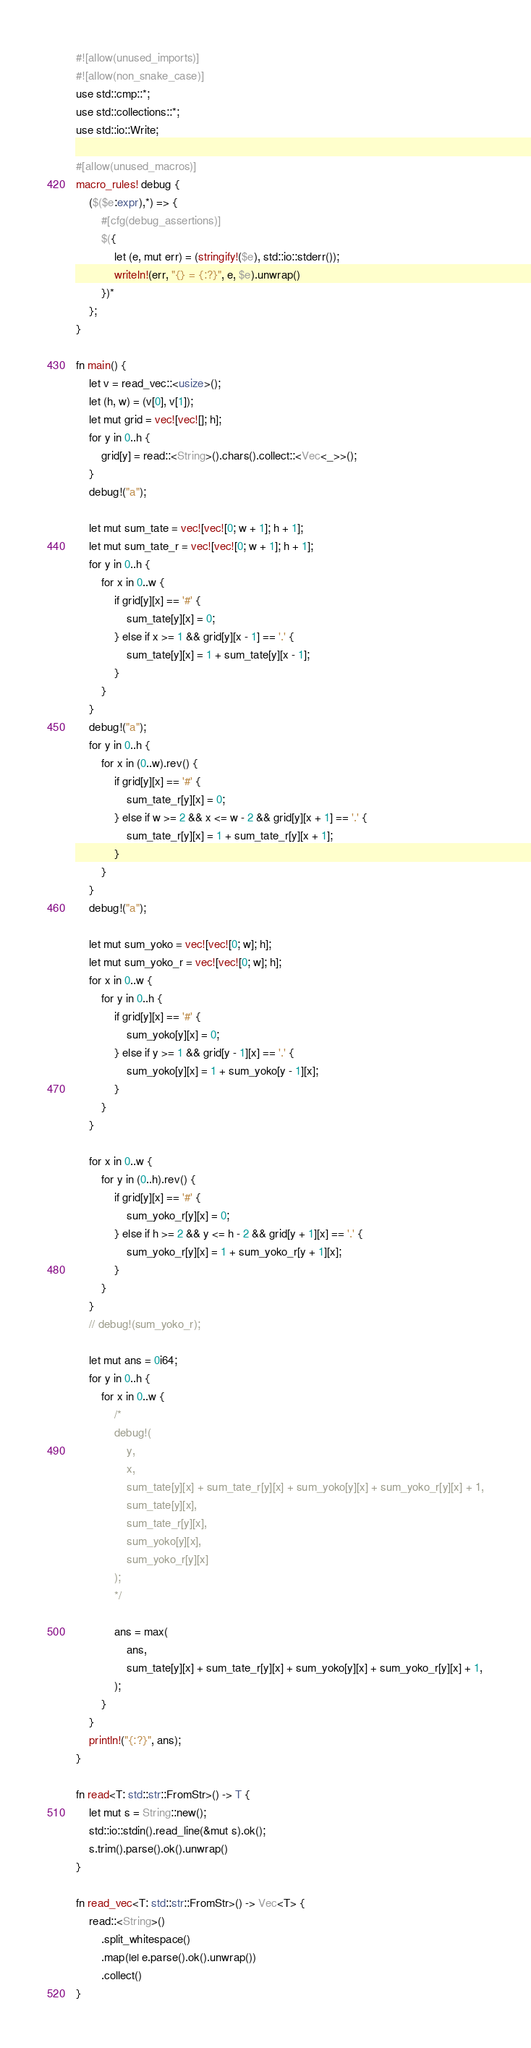<code> <loc_0><loc_0><loc_500><loc_500><_Rust_>#![allow(unused_imports)]
#![allow(non_snake_case)]
use std::cmp::*;
use std::collections::*;
use std::io::Write;

#[allow(unused_macros)]
macro_rules! debug {
    ($($e:expr),*) => {
        #[cfg(debug_assertions)]
        $({
            let (e, mut err) = (stringify!($e), std::io::stderr());
            writeln!(err, "{} = {:?}", e, $e).unwrap()
        })*
    };
}

fn main() {
    let v = read_vec::<usize>();
    let (h, w) = (v[0], v[1]);
    let mut grid = vec![vec![]; h];
    for y in 0..h {
        grid[y] = read::<String>().chars().collect::<Vec<_>>();
    }
    debug!("a");

    let mut sum_tate = vec![vec![0; w + 1]; h + 1];
    let mut sum_tate_r = vec![vec![0; w + 1]; h + 1];
    for y in 0..h {
        for x in 0..w {
            if grid[y][x] == '#' {
                sum_tate[y][x] = 0;
            } else if x >= 1 && grid[y][x - 1] == '.' {
                sum_tate[y][x] = 1 + sum_tate[y][x - 1];
            }
        }
    }
    debug!("a");
    for y in 0..h {
        for x in (0..w).rev() {
            if grid[y][x] == '#' {
                sum_tate_r[y][x] = 0;
            } else if w >= 2 && x <= w - 2 && grid[y][x + 1] == '.' {
                sum_tate_r[y][x] = 1 + sum_tate_r[y][x + 1];
            }
        }
    }
    debug!("a");

    let mut sum_yoko = vec![vec![0; w]; h];
    let mut sum_yoko_r = vec![vec![0; w]; h];
    for x in 0..w {
        for y in 0..h {
            if grid[y][x] == '#' {
                sum_yoko[y][x] = 0;
            } else if y >= 1 && grid[y - 1][x] == '.' {
                sum_yoko[y][x] = 1 + sum_yoko[y - 1][x];
            }
        }
    }

    for x in 0..w {
        for y in (0..h).rev() {
            if grid[y][x] == '#' {
                sum_yoko_r[y][x] = 0;
            } else if h >= 2 && y <= h - 2 && grid[y + 1][x] == '.' {
                sum_yoko_r[y][x] = 1 + sum_yoko_r[y + 1][x];
            }
        }
    }
    // debug!(sum_yoko_r);

    let mut ans = 0i64;
    for y in 0..h {
        for x in 0..w {
            /*
            debug!(
                y,
                x,
                sum_tate[y][x] + sum_tate_r[y][x] + sum_yoko[y][x] + sum_yoko_r[y][x] + 1,
                sum_tate[y][x],
                sum_tate_r[y][x],
                sum_yoko[y][x],
                sum_yoko_r[y][x]
            );
            */

            ans = max(
                ans,
                sum_tate[y][x] + sum_tate_r[y][x] + sum_yoko[y][x] + sum_yoko_r[y][x] + 1,
            );
        }
    }
    println!("{:?}", ans);
}

fn read<T: std::str::FromStr>() -> T {
    let mut s = String::new();
    std::io::stdin().read_line(&mut s).ok();
    s.trim().parse().ok().unwrap()
}

fn read_vec<T: std::str::FromStr>() -> Vec<T> {
    read::<String>()
        .split_whitespace()
        .map(|e| e.parse().ok().unwrap())
        .collect()
}
</code> 